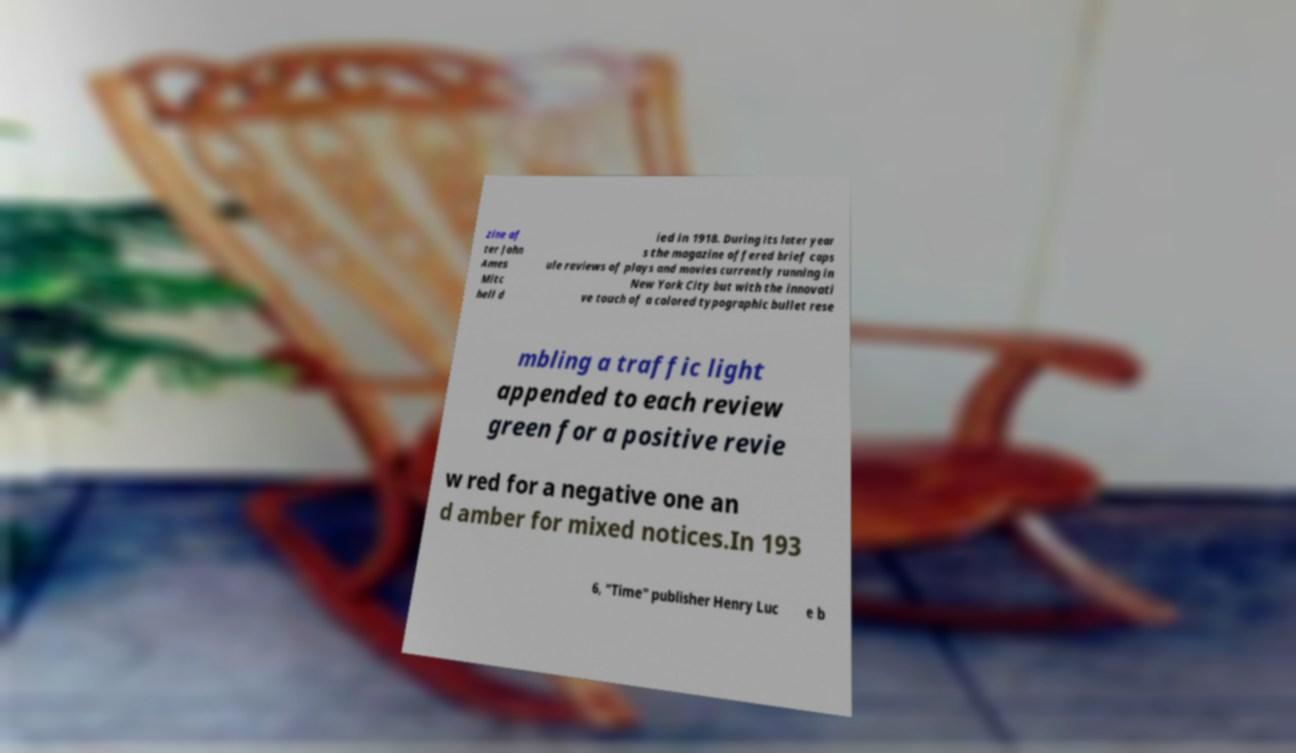Can you accurately transcribe the text from the provided image for me? zine af ter John Ames Mitc hell d ied in 1918. During its later year s the magazine offered brief caps ule reviews of plays and movies currently running in New York City but with the innovati ve touch of a colored typographic bullet rese mbling a traffic light appended to each review green for a positive revie w red for a negative one an d amber for mixed notices.In 193 6, "Time" publisher Henry Luc e b 